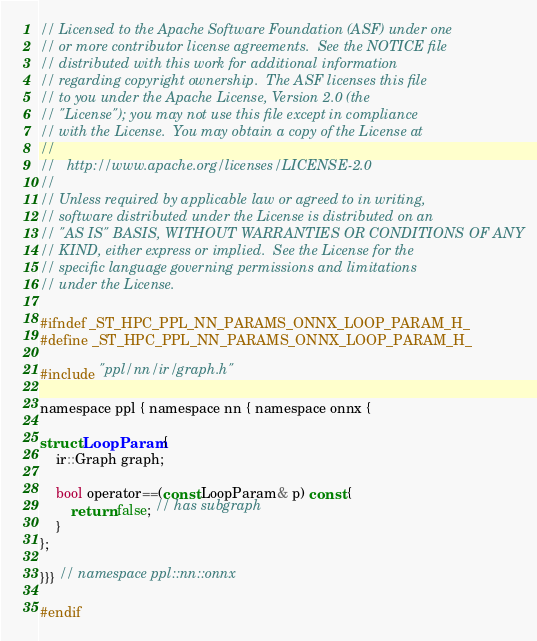<code> <loc_0><loc_0><loc_500><loc_500><_C_>// Licensed to the Apache Software Foundation (ASF) under one
// or more contributor license agreements.  See the NOTICE file
// distributed with this work for additional information
// regarding copyright ownership.  The ASF licenses this file
// to you under the Apache License, Version 2.0 (the
// "License"); you may not use this file except in compliance
// with the License.  You may obtain a copy of the License at
//
//   http://www.apache.org/licenses/LICENSE-2.0
//
// Unless required by applicable law or agreed to in writing,
// software distributed under the License is distributed on an
// "AS IS" BASIS, WITHOUT WARRANTIES OR CONDITIONS OF ANY
// KIND, either express or implied.  See the License for the
// specific language governing permissions and limitations
// under the License.

#ifndef _ST_HPC_PPL_NN_PARAMS_ONNX_LOOP_PARAM_H_
#define _ST_HPC_PPL_NN_PARAMS_ONNX_LOOP_PARAM_H_

#include "ppl/nn/ir/graph.h"

namespace ppl { namespace nn { namespace onnx {

struct LoopParam {
    ir::Graph graph;

    bool operator==(const LoopParam& p) const {
        return false; // has subgraph
    }
};

}}} // namespace ppl::nn::onnx

#endif
</code> 